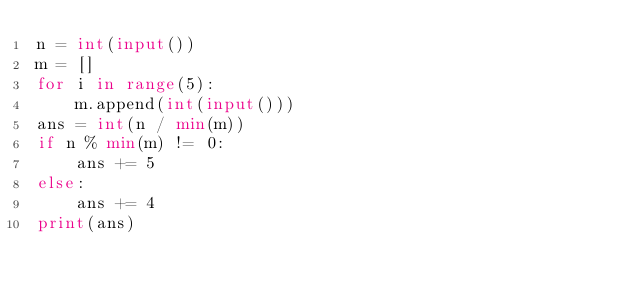Convert code to text. <code><loc_0><loc_0><loc_500><loc_500><_Python_>n = int(input())
m = []
for i in range(5):
    m.append(int(input()))
ans = int(n / min(m))
if n % min(m) != 0:
    ans += 5
else:
    ans += 4
print(ans)</code> 